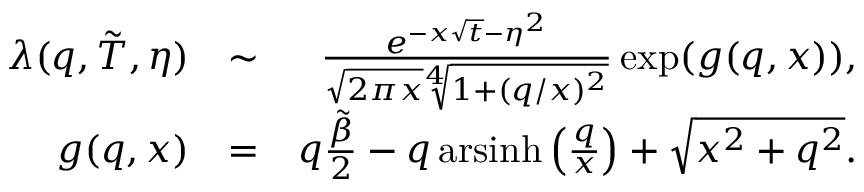<formula> <loc_0><loc_0><loc_500><loc_500>\begin{array} { r l r } { \lambda ( q , \tilde { T } , \eta ) } & { \sim } & { \frac { e ^ { - x \sqrt { t } - \eta ^ { 2 } } } { \sqrt { 2 \pi x } \sqrt { [ } 4 ] { 1 + ( q / x ) ^ { 2 } } } \exp ( g ( q , x ) ) , } \\ { g ( q , x ) } & { = } & { q \frac { \tilde { \beta } } { 2 } - q \, a r \sinh \left ( \frac { q } { x } \right ) + \sqrt { x ^ { 2 } + q ^ { 2 } } . } \end{array}</formula> 